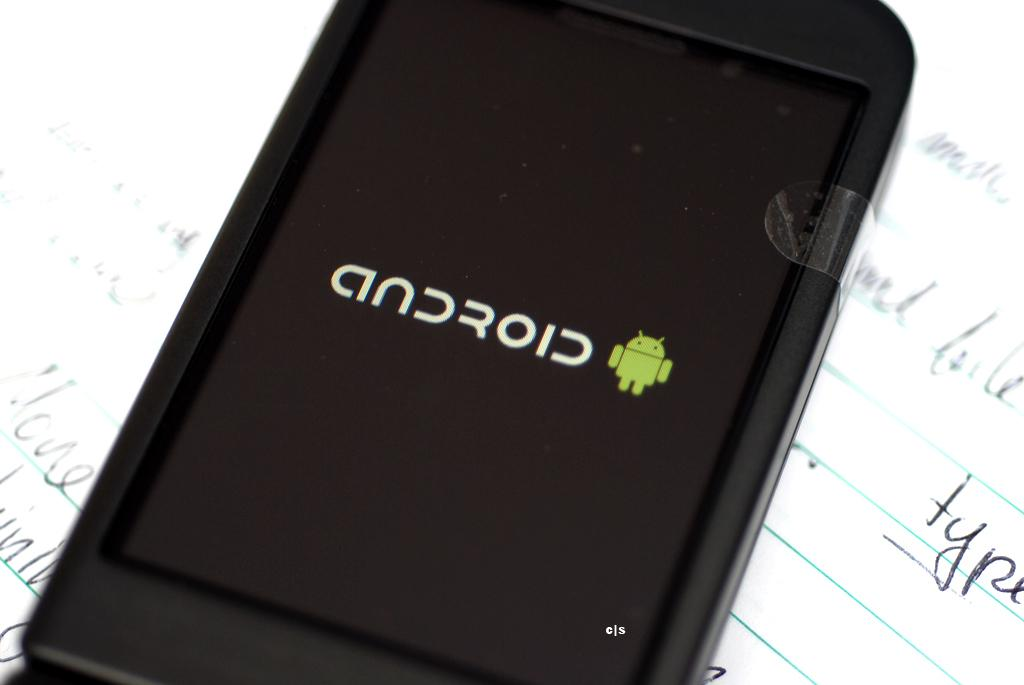<image>
Present a compact description of the photo's key features. A black phone with the word adroid displayed on its screen. 